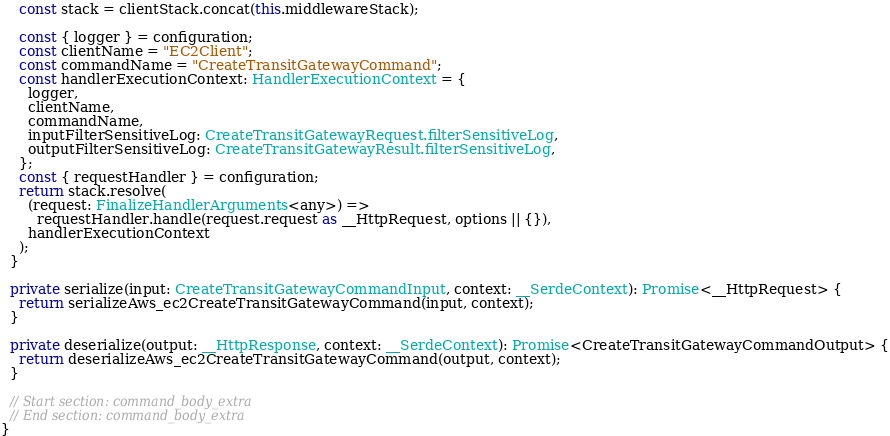<code> <loc_0><loc_0><loc_500><loc_500><_TypeScript_>
    const stack = clientStack.concat(this.middlewareStack);

    const { logger } = configuration;
    const clientName = "EC2Client";
    const commandName = "CreateTransitGatewayCommand";
    const handlerExecutionContext: HandlerExecutionContext = {
      logger,
      clientName,
      commandName,
      inputFilterSensitiveLog: CreateTransitGatewayRequest.filterSensitiveLog,
      outputFilterSensitiveLog: CreateTransitGatewayResult.filterSensitiveLog,
    };
    const { requestHandler } = configuration;
    return stack.resolve(
      (request: FinalizeHandlerArguments<any>) =>
        requestHandler.handle(request.request as __HttpRequest, options || {}),
      handlerExecutionContext
    );
  }

  private serialize(input: CreateTransitGatewayCommandInput, context: __SerdeContext): Promise<__HttpRequest> {
    return serializeAws_ec2CreateTransitGatewayCommand(input, context);
  }

  private deserialize(output: __HttpResponse, context: __SerdeContext): Promise<CreateTransitGatewayCommandOutput> {
    return deserializeAws_ec2CreateTransitGatewayCommand(output, context);
  }

  // Start section: command_body_extra
  // End section: command_body_extra
}
</code> 